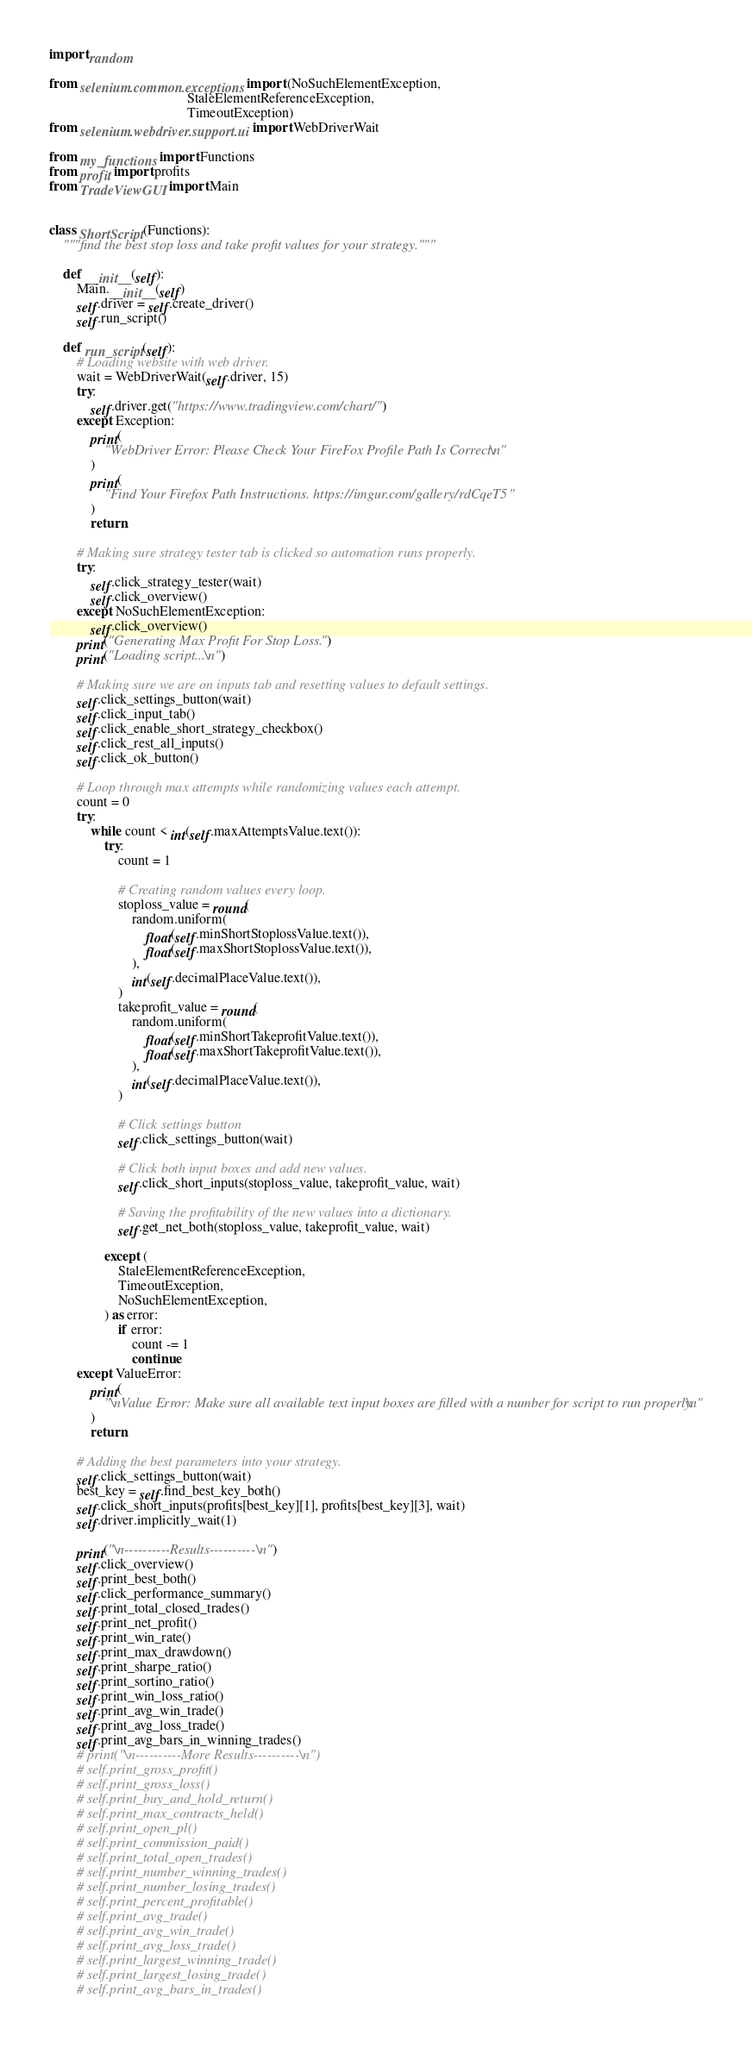<code> <loc_0><loc_0><loc_500><loc_500><_Python_>import random

from selenium.common.exceptions import (NoSuchElementException,
                                        StaleElementReferenceException,
                                        TimeoutException)
from selenium.webdriver.support.ui import WebDriverWait

from my_functions import Functions
from profit import profits
from TradeViewGUI import Main


class ShortScript(Functions):
    """find the best stop loss and take profit values for your strategy."""

    def __init__(self):
        Main.__init__(self)
        self.driver = self.create_driver()
        self.run_script()

    def run_script(self):
        # Loading website with web driver.
        wait = WebDriverWait(self.driver, 15)
        try:
            self.driver.get("https://www.tradingview.com/chart/")
        except Exception:
            print(
                "WebDriver Error: Please Check Your FireFox Profile Path Is Correct.\n"
            )
            print(
                "Find Your Firefox Path Instructions. https://imgur.com/gallery/rdCqeT5 "
            )
            return

        # Making sure strategy tester tab is clicked so automation runs properly.
        try:
            self.click_strategy_tester(wait)
            self.click_overview()
        except NoSuchElementException:
            self.click_overview()
        print("Generating Max Profit For Stop Loss.")
        print("Loading script...\n")

        # Making sure we are on inputs tab and resetting values to default settings.
        self.click_settings_button(wait)
        self.click_input_tab()
        self.click_enable_short_strategy_checkbox()
        self.click_rest_all_inputs()
        self.click_ok_button()

        # Loop through max attempts while randomizing values each attempt.
        count = 0
        try:
            while count < int(self.maxAttemptsValue.text()):
                try:
                    count = 1

                    # Creating random values every loop.
                    stoploss_value = round(
                        random.uniform(
                            float(self.minShortStoplossValue.text()),
                            float(self.maxShortStoplossValue.text()),
                        ),
                        int(self.decimalPlaceValue.text()),
                    )
                    takeprofit_value = round(
                        random.uniform(
                            float(self.minShortTakeprofitValue.text()),
                            float(self.maxShortTakeprofitValue.text()),
                        ),
                        int(self.decimalPlaceValue.text()),
                    )

                    # Click settings button
                    self.click_settings_button(wait)

                    # Click both input boxes and add new values.
                    self.click_short_inputs(stoploss_value, takeprofit_value, wait)

                    # Saving the profitability of the new values into a dictionary.
                    self.get_net_both(stoploss_value, takeprofit_value, wait)

                except (
                    StaleElementReferenceException,
                    TimeoutException,
                    NoSuchElementException,
                ) as error:
                    if error:
                        count -= 1
                        continue
        except ValueError:
            print(
                "\nValue Error: Make sure all available text input boxes are filled with a number for script to run properly.\n"
            )
            return

        # Adding the best parameters into your strategy.
        self.click_settings_button(wait)
        best_key = self.find_best_key_both()
        self.click_short_inputs(profits[best_key][1], profits[best_key][3], wait)
        self.driver.implicitly_wait(1)

        print("\n----------Results----------\n")
        self.click_overview()
        self.print_best_both()
        self.click_performance_summary()
        self.print_total_closed_trades()
        self.print_net_profit()
        self.print_win_rate()
        self.print_max_drawdown()
        self.print_sharpe_ratio()
        self.print_sortino_ratio()
        self.print_win_loss_ratio()
        self.print_avg_win_trade()
        self.print_avg_loss_trade()
        self.print_avg_bars_in_winning_trades()
        # print("\n----------More Results----------\n")
        # self.print_gross_profit()
        # self.print_gross_loss()
        # self.print_buy_and_hold_return()
        # self.print_max_contracts_held()
        # self.print_open_pl()
        # self.print_commission_paid()
        # self.print_total_open_trades()
        # self.print_number_winning_trades()
        # self.print_number_losing_trades()
        # self.print_percent_profitable()
        # self.print_avg_trade()
        # self.print_avg_win_trade()
        # self.print_avg_loss_trade()
        # self.print_largest_winning_trade()
        # self.print_largest_losing_trade()
        # self.print_avg_bars_in_trades()</code> 